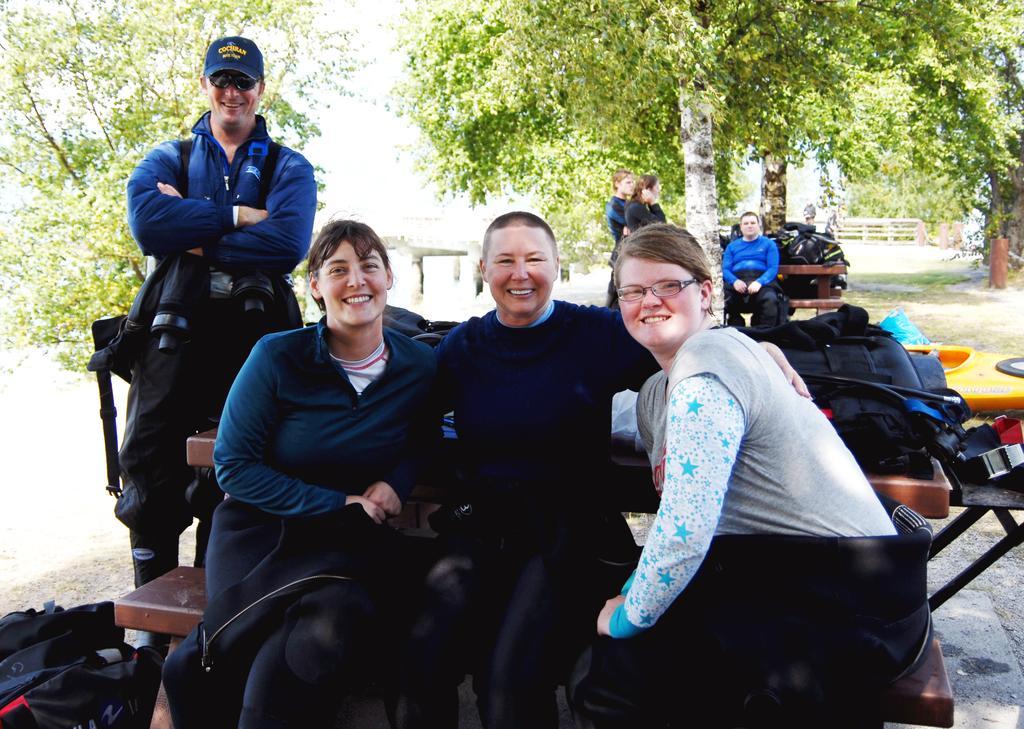In one or two sentences, can you explain what this image depicts? In the picture I can see people among them some are sitting and some are standing. The people in the front are smiling. I can also see bags and some other objects on table and on the ground. In the background I can see trees, fence and some other objects. 